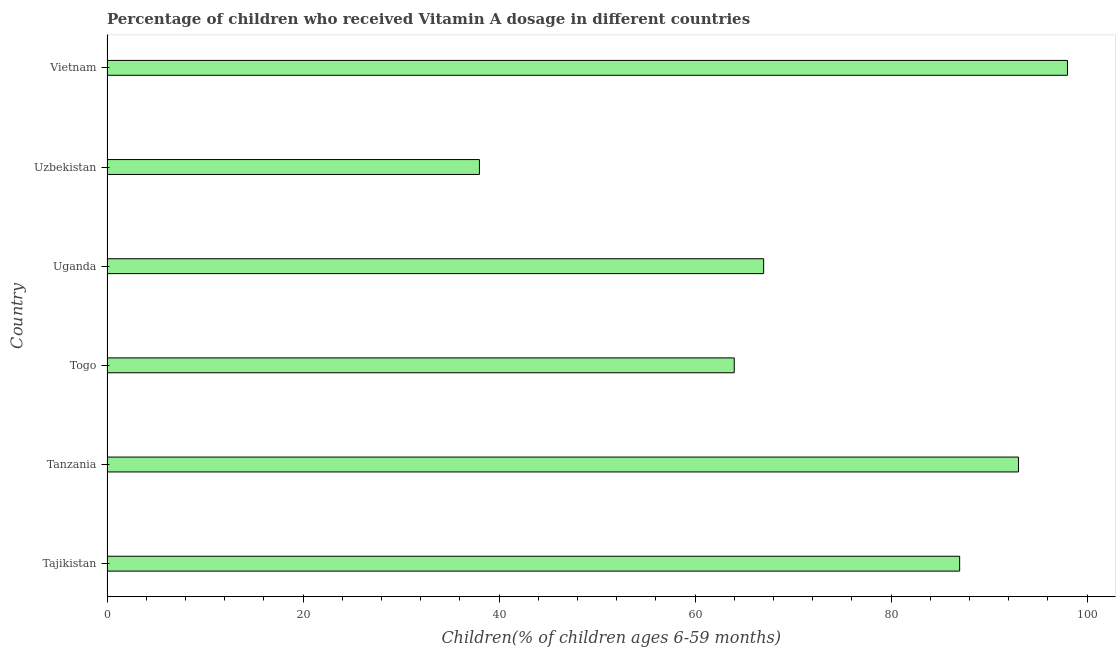What is the title of the graph?
Your response must be concise. Percentage of children who received Vitamin A dosage in different countries. What is the label or title of the X-axis?
Ensure brevity in your answer.  Children(% of children ages 6-59 months). What is the label or title of the Y-axis?
Keep it short and to the point. Country. What is the vitamin a supplementation coverage rate in Tajikistan?
Offer a very short reply. 87. Across all countries, what is the minimum vitamin a supplementation coverage rate?
Offer a very short reply. 38. In which country was the vitamin a supplementation coverage rate maximum?
Provide a succinct answer. Vietnam. In which country was the vitamin a supplementation coverage rate minimum?
Your response must be concise. Uzbekistan. What is the sum of the vitamin a supplementation coverage rate?
Your answer should be very brief. 447. What is the average vitamin a supplementation coverage rate per country?
Offer a very short reply. 74.5. What is the median vitamin a supplementation coverage rate?
Your answer should be compact. 77. In how many countries, is the vitamin a supplementation coverage rate greater than 76 %?
Your answer should be very brief. 3. What is the ratio of the vitamin a supplementation coverage rate in Tanzania to that in Vietnam?
Keep it short and to the point. 0.95. Is the difference between the vitamin a supplementation coverage rate in Tanzania and Uzbekistan greater than the difference between any two countries?
Your answer should be very brief. No. What is the difference between the highest and the second highest vitamin a supplementation coverage rate?
Your answer should be very brief. 5. Is the sum of the vitamin a supplementation coverage rate in Uganda and Uzbekistan greater than the maximum vitamin a supplementation coverage rate across all countries?
Make the answer very short. Yes. What is the difference between the highest and the lowest vitamin a supplementation coverage rate?
Offer a very short reply. 60. How many bars are there?
Offer a terse response. 6. What is the difference between two consecutive major ticks on the X-axis?
Keep it short and to the point. 20. What is the Children(% of children ages 6-59 months) of Tanzania?
Your answer should be very brief. 93. What is the Children(% of children ages 6-59 months) in Togo?
Make the answer very short. 64. What is the Children(% of children ages 6-59 months) in Uganda?
Make the answer very short. 67. What is the Children(% of children ages 6-59 months) in Uzbekistan?
Your answer should be compact. 38. What is the difference between the Children(% of children ages 6-59 months) in Tajikistan and Uganda?
Give a very brief answer. 20. What is the difference between the Children(% of children ages 6-59 months) in Tajikistan and Uzbekistan?
Offer a very short reply. 49. What is the difference between the Children(% of children ages 6-59 months) in Tanzania and Togo?
Offer a terse response. 29. What is the difference between the Children(% of children ages 6-59 months) in Tanzania and Uganda?
Your answer should be very brief. 26. What is the difference between the Children(% of children ages 6-59 months) in Tanzania and Uzbekistan?
Provide a short and direct response. 55. What is the difference between the Children(% of children ages 6-59 months) in Tanzania and Vietnam?
Ensure brevity in your answer.  -5. What is the difference between the Children(% of children ages 6-59 months) in Togo and Uzbekistan?
Keep it short and to the point. 26. What is the difference between the Children(% of children ages 6-59 months) in Togo and Vietnam?
Keep it short and to the point. -34. What is the difference between the Children(% of children ages 6-59 months) in Uganda and Uzbekistan?
Offer a terse response. 29. What is the difference between the Children(% of children ages 6-59 months) in Uganda and Vietnam?
Provide a succinct answer. -31. What is the difference between the Children(% of children ages 6-59 months) in Uzbekistan and Vietnam?
Offer a terse response. -60. What is the ratio of the Children(% of children ages 6-59 months) in Tajikistan to that in Tanzania?
Your answer should be compact. 0.94. What is the ratio of the Children(% of children ages 6-59 months) in Tajikistan to that in Togo?
Your response must be concise. 1.36. What is the ratio of the Children(% of children ages 6-59 months) in Tajikistan to that in Uganda?
Offer a terse response. 1.3. What is the ratio of the Children(% of children ages 6-59 months) in Tajikistan to that in Uzbekistan?
Provide a short and direct response. 2.29. What is the ratio of the Children(% of children ages 6-59 months) in Tajikistan to that in Vietnam?
Give a very brief answer. 0.89. What is the ratio of the Children(% of children ages 6-59 months) in Tanzania to that in Togo?
Your response must be concise. 1.45. What is the ratio of the Children(% of children ages 6-59 months) in Tanzania to that in Uganda?
Your answer should be very brief. 1.39. What is the ratio of the Children(% of children ages 6-59 months) in Tanzania to that in Uzbekistan?
Provide a succinct answer. 2.45. What is the ratio of the Children(% of children ages 6-59 months) in Tanzania to that in Vietnam?
Make the answer very short. 0.95. What is the ratio of the Children(% of children ages 6-59 months) in Togo to that in Uganda?
Your answer should be compact. 0.95. What is the ratio of the Children(% of children ages 6-59 months) in Togo to that in Uzbekistan?
Make the answer very short. 1.68. What is the ratio of the Children(% of children ages 6-59 months) in Togo to that in Vietnam?
Provide a succinct answer. 0.65. What is the ratio of the Children(% of children ages 6-59 months) in Uganda to that in Uzbekistan?
Provide a short and direct response. 1.76. What is the ratio of the Children(% of children ages 6-59 months) in Uganda to that in Vietnam?
Offer a terse response. 0.68. What is the ratio of the Children(% of children ages 6-59 months) in Uzbekistan to that in Vietnam?
Provide a short and direct response. 0.39. 